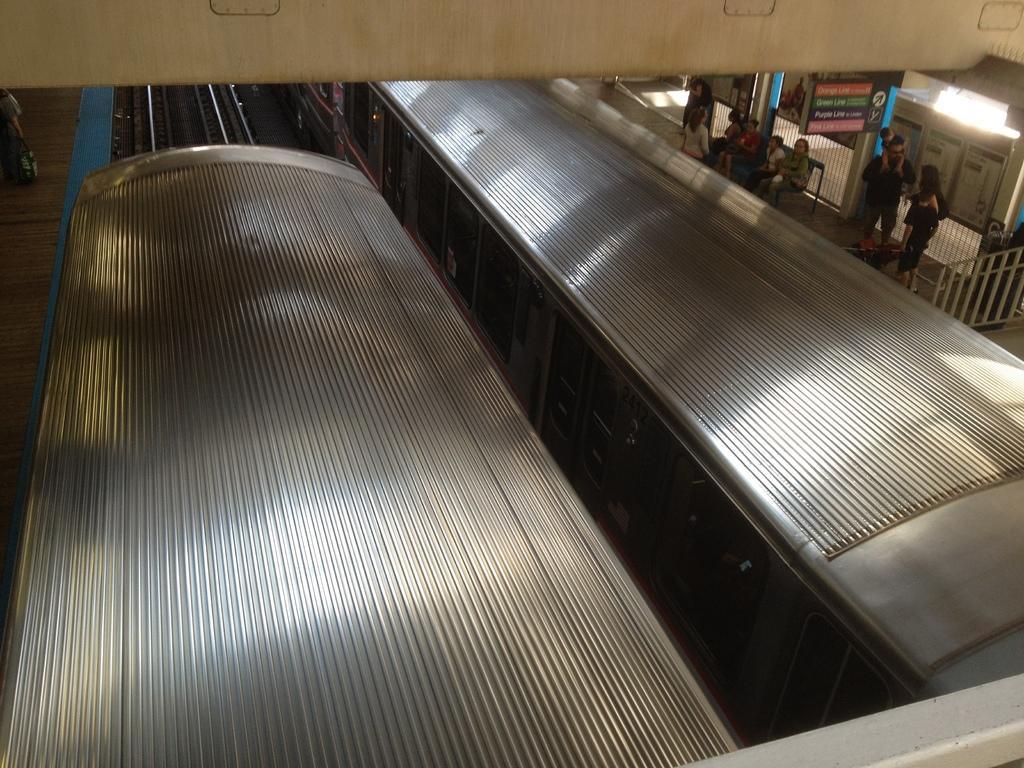How would you summarize this image in a sentence or two? In this image there are trains, there are persons standing and sitting, there is a board with some text written on it and there is a railing, there is a wall and on the left side there is an object which is black in colour. On the right side there is a fence which is black in colour behind the persons. 